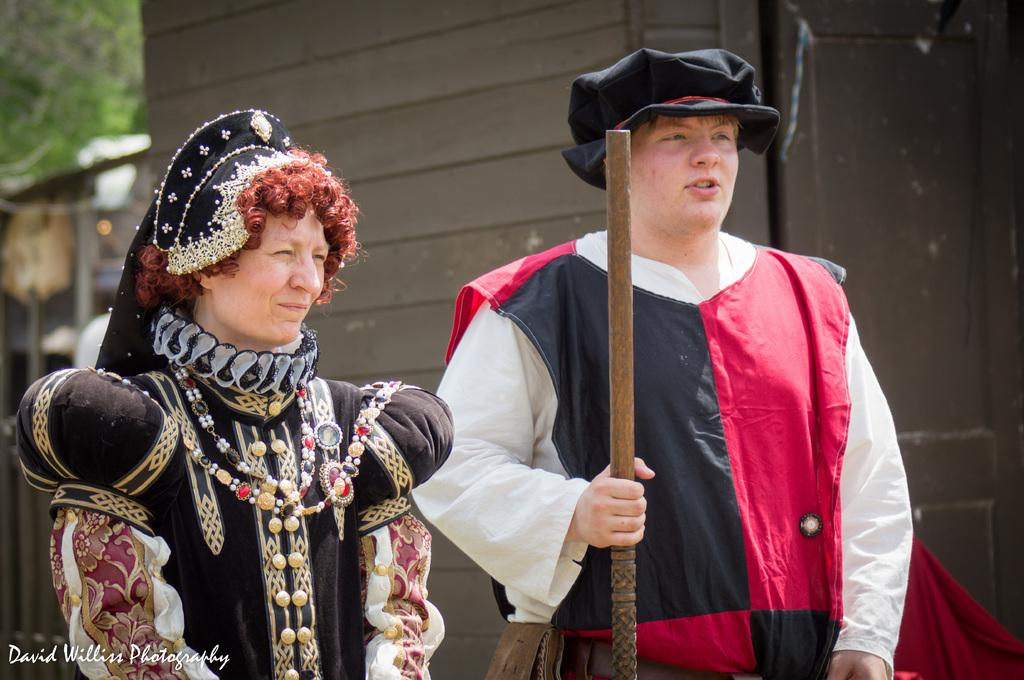How many people are present in the image? There are two people, a man and a woman, present in the image. What are the man and woman wearing? Both the man and woman are wearing costumes. What is the man holding in the image? The man is holding a wooden stick. What can be seen on the backside of the image? There is a cloth visible on the backside. What type of structure can be seen in the image? There is a wall and a door visible in the image. What type of twig is the man using to scratch his back in the image? There is no twig present in the image, and the man is not scratching his back. What type of shirt is the woman wearing in the image? The woman is not wearing a shirt in the image; she is wearing a costume. 